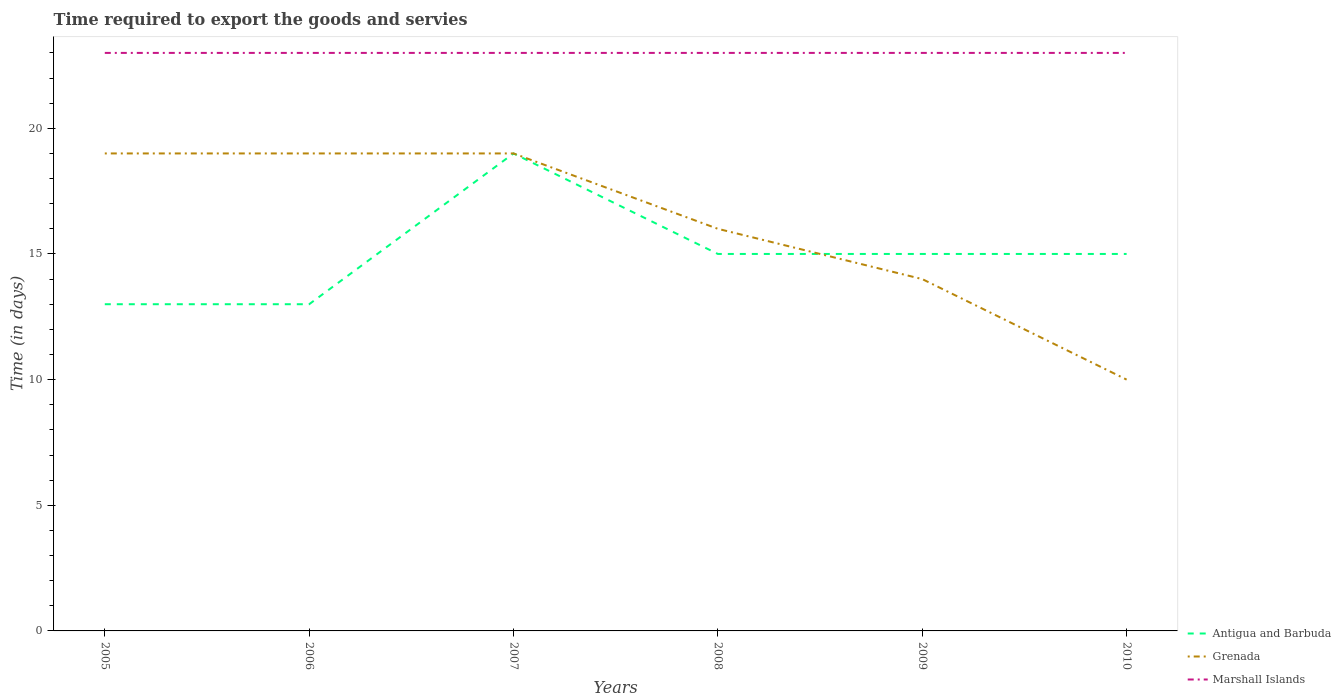How many different coloured lines are there?
Ensure brevity in your answer.  3. Does the line corresponding to Marshall Islands intersect with the line corresponding to Antigua and Barbuda?
Keep it short and to the point. No. Across all years, what is the maximum number of days required to export the goods and services in Antigua and Barbuda?
Offer a very short reply. 13. In which year was the number of days required to export the goods and services in Marshall Islands maximum?
Ensure brevity in your answer.  2005. What is the total number of days required to export the goods and services in Marshall Islands in the graph?
Offer a very short reply. 0. How many lines are there?
Give a very brief answer. 3. How many years are there in the graph?
Give a very brief answer. 6. Are the values on the major ticks of Y-axis written in scientific E-notation?
Keep it short and to the point. No. Where does the legend appear in the graph?
Give a very brief answer. Bottom right. How are the legend labels stacked?
Make the answer very short. Vertical. What is the title of the graph?
Offer a very short reply. Time required to export the goods and servies. Does "Senegal" appear as one of the legend labels in the graph?
Provide a succinct answer. No. What is the label or title of the Y-axis?
Provide a succinct answer. Time (in days). What is the Time (in days) of Antigua and Barbuda in 2006?
Ensure brevity in your answer.  13. What is the Time (in days) in Antigua and Barbuda in 2007?
Offer a terse response. 19. What is the Time (in days) in Grenada in 2008?
Your answer should be very brief. 16. What is the Time (in days) of Marshall Islands in 2008?
Ensure brevity in your answer.  23. What is the Time (in days) of Antigua and Barbuda in 2009?
Your answer should be compact. 15. What is the Time (in days) of Grenada in 2009?
Offer a terse response. 14. What is the Time (in days) of Marshall Islands in 2009?
Give a very brief answer. 23. What is the Time (in days) of Grenada in 2010?
Keep it short and to the point. 10. Across all years, what is the maximum Time (in days) of Antigua and Barbuda?
Give a very brief answer. 19. Across all years, what is the maximum Time (in days) in Marshall Islands?
Give a very brief answer. 23. Across all years, what is the minimum Time (in days) of Antigua and Barbuda?
Offer a terse response. 13. Across all years, what is the minimum Time (in days) in Grenada?
Your answer should be compact. 10. Across all years, what is the minimum Time (in days) in Marshall Islands?
Your answer should be very brief. 23. What is the total Time (in days) of Grenada in the graph?
Provide a short and direct response. 97. What is the total Time (in days) of Marshall Islands in the graph?
Provide a succinct answer. 138. What is the difference between the Time (in days) in Antigua and Barbuda in 2005 and that in 2006?
Provide a short and direct response. 0. What is the difference between the Time (in days) in Grenada in 2005 and that in 2006?
Provide a short and direct response. 0. What is the difference between the Time (in days) in Marshall Islands in 2005 and that in 2006?
Provide a succinct answer. 0. What is the difference between the Time (in days) of Antigua and Barbuda in 2005 and that in 2008?
Provide a succinct answer. -2. What is the difference between the Time (in days) in Antigua and Barbuda in 2005 and that in 2009?
Give a very brief answer. -2. What is the difference between the Time (in days) in Grenada in 2005 and that in 2009?
Offer a terse response. 5. What is the difference between the Time (in days) of Antigua and Barbuda in 2006 and that in 2007?
Make the answer very short. -6. What is the difference between the Time (in days) in Marshall Islands in 2006 and that in 2008?
Make the answer very short. 0. What is the difference between the Time (in days) in Antigua and Barbuda in 2006 and that in 2009?
Give a very brief answer. -2. What is the difference between the Time (in days) in Grenada in 2006 and that in 2009?
Your response must be concise. 5. What is the difference between the Time (in days) in Marshall Islands in 2006 and that in 2009?
Your answer should be very brief. 0. What is the difference between the Time (in days) of Antigua and Barbuda in 2006 and that in 2010?
Your response must be concise. -2. What is the difference between the Time (in days) of Grenada in 2006 and that in 2010?
Your answer should be compact. 9. What is the difference between the Time (in days) of Marshall Islands in 2006 and that in 2010?
Your answer should be very brief. 0. What is the difference between the Time (in days) of Marshall Islands in 2007 and that in 2008?
Make the answer very short. 0. What is the difference between the Time (in days) in Antigua and Barbuda in 2007 and that in 2009?
Give a very brief answer. 4. What is the difference between the Time (in days) in Grenada in 2007 and that in 2009?
Keep it short and to the point. 5. What is the difference between the Time (in days) in Antigua and Barbuda in 2007 and that in 2010?
Make the answer very short. 4. What is the difference between the Time (in days) of Grenada in 2007 and that in 2010?
Offer a very short reply. 9. What is the difference between the Time (in days) of Marshall Islands in 2007 and that in 2010?
Offer a very short reply. 0. What is the difference between the Time (in days) in Antigua and Barbuda in 2008 and that in 2009?
Make the answer very short. 0. What is the difference between the Time (in days) in Grenada in 2008 and that in 2010?
Offer a terse response. 6. What is the difference between the Time (in days) of Antigua and Barbuda in 2005 and the Time (in days) of Marshall Islands in 2006?
Your response must be concise. -10. What is the difference between the Time (in days) of Grenada in 2005 and the Time (in days) of Marshall Islands in 2006?
Provide a succinct answer. -4. What is the difference between the Time (in days) of Antigua and Barbuda in 2005 and the Time (in days) of Marshall Islands in 2007?
Make the answer very short. -10. What is the difference between the Time (in days) in Grenada in 2005 and the Time (in days) in Marshall Islands in 2007?
Your response must be concise. -4. What is the difference between the Time (in days) in Antigua and Barbuda in 2005 and the Time (in days) in Marshall Islands in 2008?
Offer a very short reply. -10. What is the difference between the Time (in days) of Antigua and Barbuda in 2005 and the Time (in days) of Grenada in 2009?
Provide a succinct answer. -1. What is the difference between the Time (in days) of Antigua and Barbuda in 2005 and the Time (in days) of Marshall Islands in 2010?
Provide a succinct answer. -10. What is the difference between the Time (in days) of Grenada in 2005 and the Time (in days) of Marshall Islands in 2010?
Keep it short and to the point. -4. What is the difference between the Time (in days) in Antigua and Barbuda in 2006 and the Time (in days) in Marshall Islands in 2007?
Make the answer very short. -10. What is the difference between the Time (in days) of Antigua and Barbuda in 2006 and the Time (in days) of Marshall Islands in 2009?
Give a very brief answer. -10. What is the difference between the Time (in days) of Antigua and Barbuda in 2006 and the Time (in days) of Grenada in 2010?
Keep it short and to the point. 3. What is the difference between the Time (in days) in Antigua and Barbuda in 2006 and the Time (in days) in Marshall Islands in 2010?
Your response must be concise. -10. What is the difference between the Time (in days) of Antigua and Barbuda in 2007 and the Time (in days) of Grenada in 2008?
Your answer should be compact. 3. What is the difference between the Time (in days) of Antigua and Barbuda in 2007 and the Time (in days) of Marshall Islands in 2009?
Keep it short and to the point. -4. What is the difference between the Time (in days) in Antigua and Barbuda in 2007 and the Time (in days) in Marshall Islands in 2010?
Give a very brief answer. -4. What is the difference between the Time (in days) in Antigua and Barbuda in 2008 and the Time (in days) in Grenada in 2010?
Give a very brief answer. 5. What is the average Time (in days) of Antigua and Barbuda per year?
Ensure brevity in your answer.  15. What is the average Time (in days) of Grenada per year?
Your response must be concise. 16.17. What is the average Time (in days) of Marshall Islands per year?
Offer a very short reply. 23. In the year 2005, what is the difference between the Time (in days) of Antigua and Barbuda and Time (in days) of Grenada?
Ensure brevity in your answer.  -6. In the year 2005, what is the difference between the Time (in days) in Grenada and Time (in days) in Marshall Islands?
Make the answer very short. -4. In the year 2006, what is the difference between the Time (in days) of Grenada and Time (in days) of Marshall Islands?
Your answer should be compact. -4. In the year 2007, what is the difference between the Time (in days) in Antigua and Barbuda and Time (in days) in Grenada?
Your answer should be compact. 0. In the year 2008, what is the difference between the Time (in days) in Antigua and Barbuda and Time (in days) in Grenada?
Provide a succinct answer. -1. In the year 2008, what is the difference between the Time (in days) in Grenada and Time (in days) in Marshall Islands?
Provide a succinct answer. -7. In the year 2010, what is the difference between the Time (in days) of Grenada and Time (in days) of Marshall Islands?
Your answer should be very brief. -13. What is the ratio of the Time (in days) of Marshall Islands in 2005 to that in 2006?
Offer a very short reply. 1. What is the ratio of the Time (in days) of Antigua and Barbuda in 2005 to that in 2007?
Provide a short and direct response. 0.68. What is the ratio of the Time (in days) in Grenada in 2005 to that in 2007?
Offer a terse response. 1. What is the ratio of the Time (in days) in Marshall Islands in 2005 to that in 2007?
Give a very brief answer. 1. What is the ratio of the Time (in days) in Antigua and Barbuda in 2005 to that in 2008?
Your answer should be compact. 0.87. What is the ratio of the Time (in days) in Grenada in 2005 to that in 2008?
Offer a terse response. 1.19. What is the ratio of the Time (in days) of Antigua and Barbuda in 2005 to that in 2009?
Your response must be concise. 0.87. What is the ratio of the Time (in days) of Grenada in 2005 to that in 2009?
Offer a terse response. 1.36. What is the ratio of the Time (in days) of Marshall Islands in 2005 to that in 2009?
Your response must be concise. 1. What is the ratio of the Time (in days) in Antigua and Barbuda in 2005 to that in 2010?
Offer a very short reply. 0.87. What is the ratio of the Time (in days) in Marshall Islands in 2005 to that in 2010?
Ensure brevity in your answer.  1. What is the ratio of the Time (in days) in Antigua and Barbuda in 2006 to that in 2007?
Keep it short and to the point. 0.68. What is the ratio of the Time (in days) of Grenada in 2006 to that in 2007?
Offer a very short reply. 1. What is the ratio of the Time (in days) in Antigua and Barbuda in 2006 to that in 2008?
Offer a very short reply. 0.87. What is the ratio of the Time (in days) in Grenada in 2006 to that in 2008?
Ensure brevity in your answer.  1.19. What is the ratio of the Time (in days) in Marshall Islands in 2006 to that in 2008?
Offer a terse response. 1. What is the ratio of the Time (in days) of Antigua and Barbuda in 2006 to that in 2009?
Your response must be concise. 0.87. What is the ratio of the Time (in days) in Grenada in 2006 to that in 2009?
Give a very brief answer. 1.36. What is the ratio of the Time (in days) of Antigua and Barbuda in 2006 to that in 2010?
Keep it short and to the point. 0.87. What is the ratio of the Time (in days) in Marshall Islands in 2006 to that in 2010?
Make the answer very short. 1. What is the ratio of the Time (in days) of Antigua and Barbuda in 2007 to that in 2008?
Give a very brief answer. 1.27. What is the ratio of the Time (in days) in Grenada in 2007 to that in 2008?
Make the answer very short. 1.19. What is the ratio of the Time (in days) of Antigua and Barbuda in 2007 to that in 2009?
Your answer should be very brief. 1.27. What is the ratio of the Time (in days) in Grenada in 2007 to that in 2009?
Offer a terse response. 1.36. What is the ratio of the Time (in days) in Marshall Islands in 2007 to that in 2009?
Give a very brief answer. 1. What is the ratio of the Time (in days) in Antigua and Barbuda in 2007 to that in 2010?
Make the answer very short. 1.27. What is the ratio of the Time (in days) of Antigua and Barbuda in 2008 to that in 2009?
Your answer should be very brief. 1. What is the ratio of the Time (in days) in Grenada in 2008 to that in 2009?
Keep it short and to the point. 1.14. What is the ratio of the Time (in days) in Marshall Islands in 2008 to that in 2009?
Provide a succinct answer. 1. What is the ratio of the Time (in days) of Antigua and Barbuda in 2008 to that in 2010?
Make the answer very short. 1. What is the ratio of the Time (in days) in Grenada in 2008 to that in 2010?
Your response must be concise. 1.6. What is the ratio of the Time (in days) in Marshall Islands in 2008 to that in 2010?
Offer a very short reply. 1. What is the ratio of the Time (in days) of Antigua and Barbuda in 2009 to that in 2010?
Your answer should be very brief. 1. What is the ratio of the Time (in days) in Grenada in 2009 to that in 2010?
Your response must be concise. 1.4. What is the difference between the highest and the second highest Time (in days) in Grenada?
Provide a succinct answer. 0. What is the difference between the highest and the second highest Time (in days) of Marshall Islands?
Ensure brevity in your answer.  0. What is the difference between the highest and the lowest Time (in days) in Grenada?
Give a very brief answer. 9. 